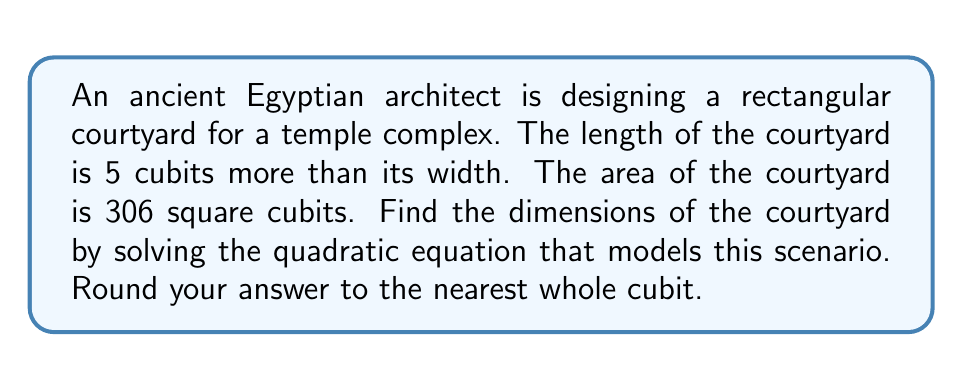Solve this math problem. Let's approach this step-by-step:

1) Let $x$ represent the width of the courtyard in cubits.
   Then, the length would be $x + 5$ cubits.

2) The area of a rectangle is given by length × width. So we can write:
   $x(x + 5) = 306$

3) Expanding this equation:
   $x^2 + 5x = 306$

4) Rearranging to standard form $(ax^2 + bx + c = 0)$:
   $x^2 + 5x - 306 = 0$

5) We can solve this using the quadratic formula: $x = \frac{-b \pm \sqrt{b^2 - 4ac}}{2a}$
   Where $a = 1$, $b = 5$, and $c = -306$

6) Substituting into the quadratic formula:
   $$x = \frac{-5 \pm \sqrt{5^2 - 4(1)(-306)}}{2(1)}$$

7) Simplifying:
   $$x = \frac{-5 \pm \sqrt{25 + 1224}}{2} = \frac{-5 \pm \sqrt{1249}}{2}$$

8) Calculating:
   $$x = \frac{-5 \pm 35.34}{2}$$

9) This gives us two solutions:
   $$x = \frac{-5 + 35.34}{2} = 15.17$$ or $$x = \frac{-5 - 35.34}{2} = -20.17$$

10) Since we're dealing with physical dimensions, we can discard the negative solution.

11) Rounding to the nearest whole cubit:
    Width = 15 cubits
    Length = 15 + 5 = 20 cubits

We can verify: 15 × 20 = 300, which is close to our target of 306 square cubits (the small difference is due to rounding).
Answer: The dimensions of the courtyard are approximately 15 cubits wide and 20 cubits long. 